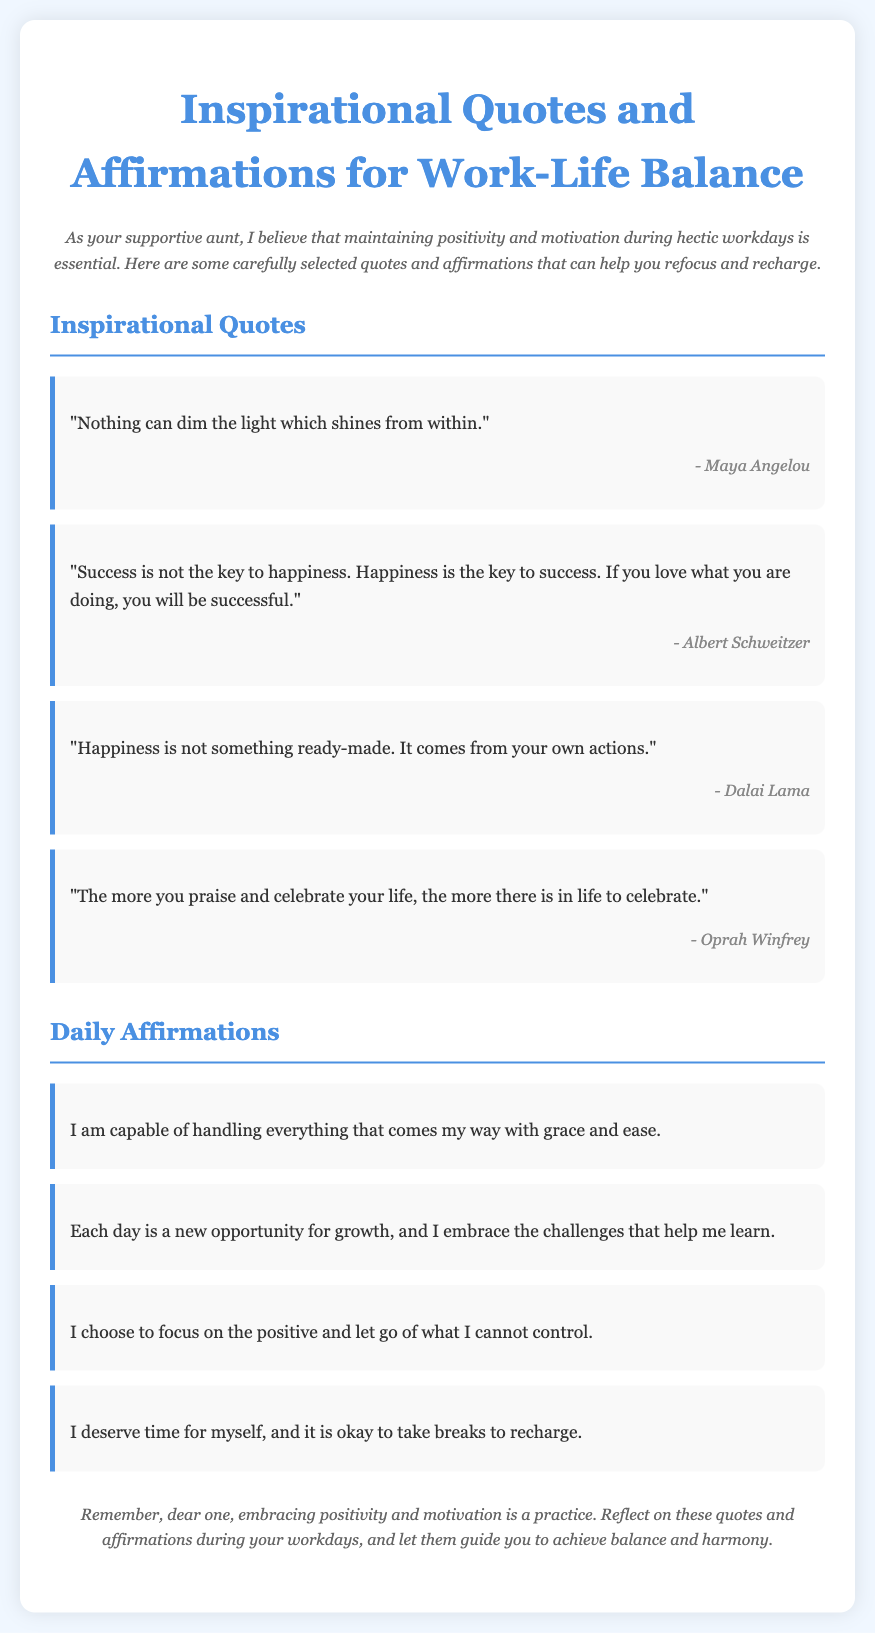What is the title of the document? The title is specified in the <title> tag of the HTML, which is "Inspirational Quotes and Affirmations for Work-Life Balance."
Answer: Inspirational Quotes and Affirmations for Work-Life Balance Who is the author of the first quote? The first quote is attributed to Maya Angelou, which is mentioned directly after the quote in the document.
Answer: Maya Angelou How many quotes are provided in the document? The quotes are listed under a section, and the total number can be counted from that section, which shows four quotes.
Answer: 4 What is the theme of the affirmations? The affirmations focus on positivity and self-empowerment, which is evident in their content about grace, growth, and self-care.
Answer: Positivity and self-empowerment What does the introduction suggest about the importance of the content? The introduction emphasizes that maintaining positivity and motivation during hectic workdays is essential, indicating its significance.
Answer: Essential 